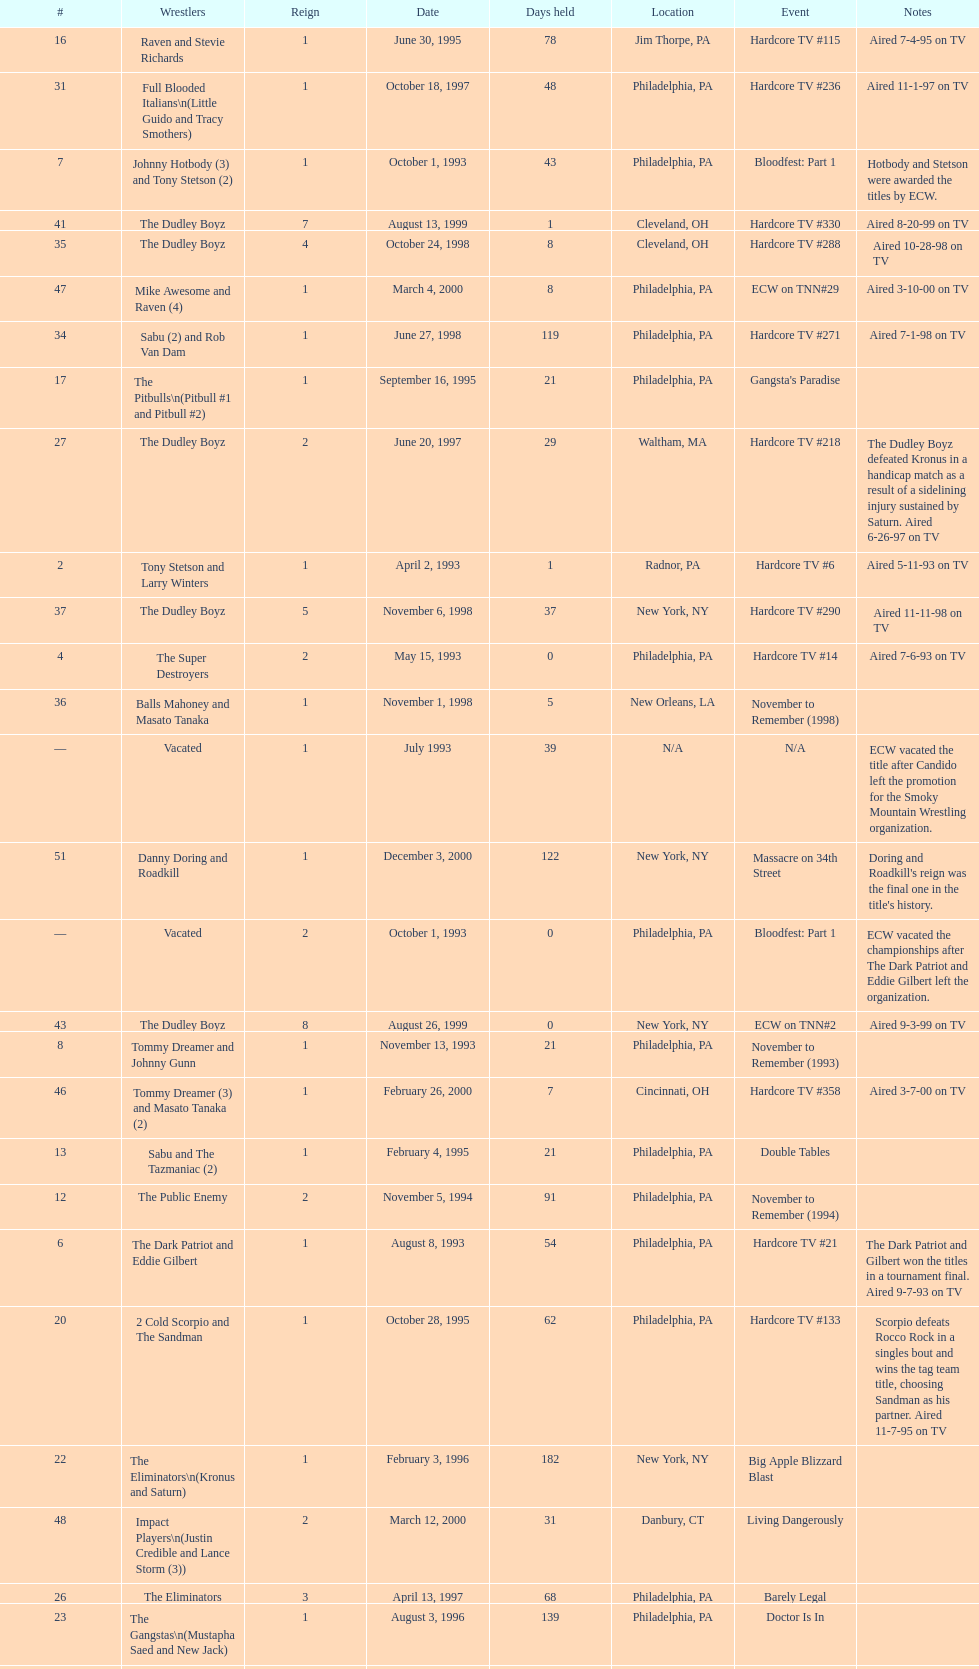Which was the only team to win by forfeit? The Dudley Boyz. 